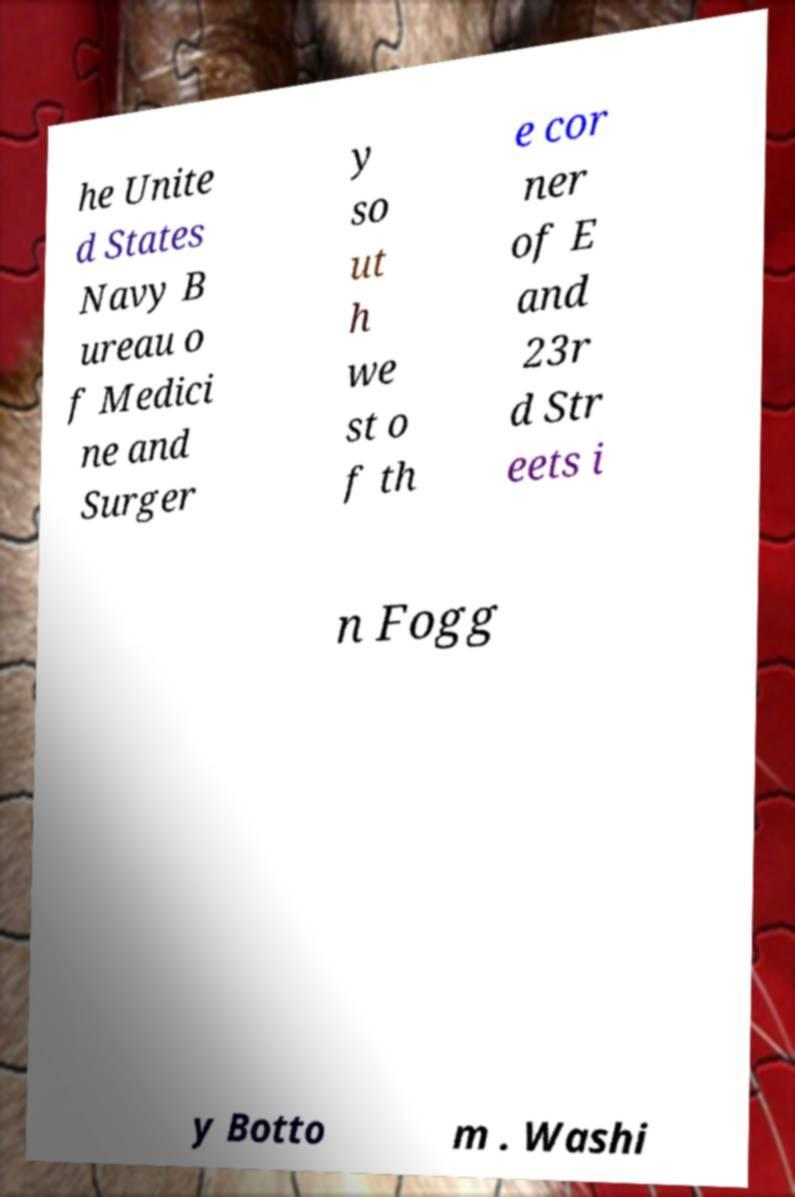Could you assist in decoding the text presented in this image and type it out clearly? he Unite d States Navy B ureau o f Medici ne and Surger y so ut h we st o f th e cor ner of E and 23r d Str eets i n Fogg y Botto m . Washi 